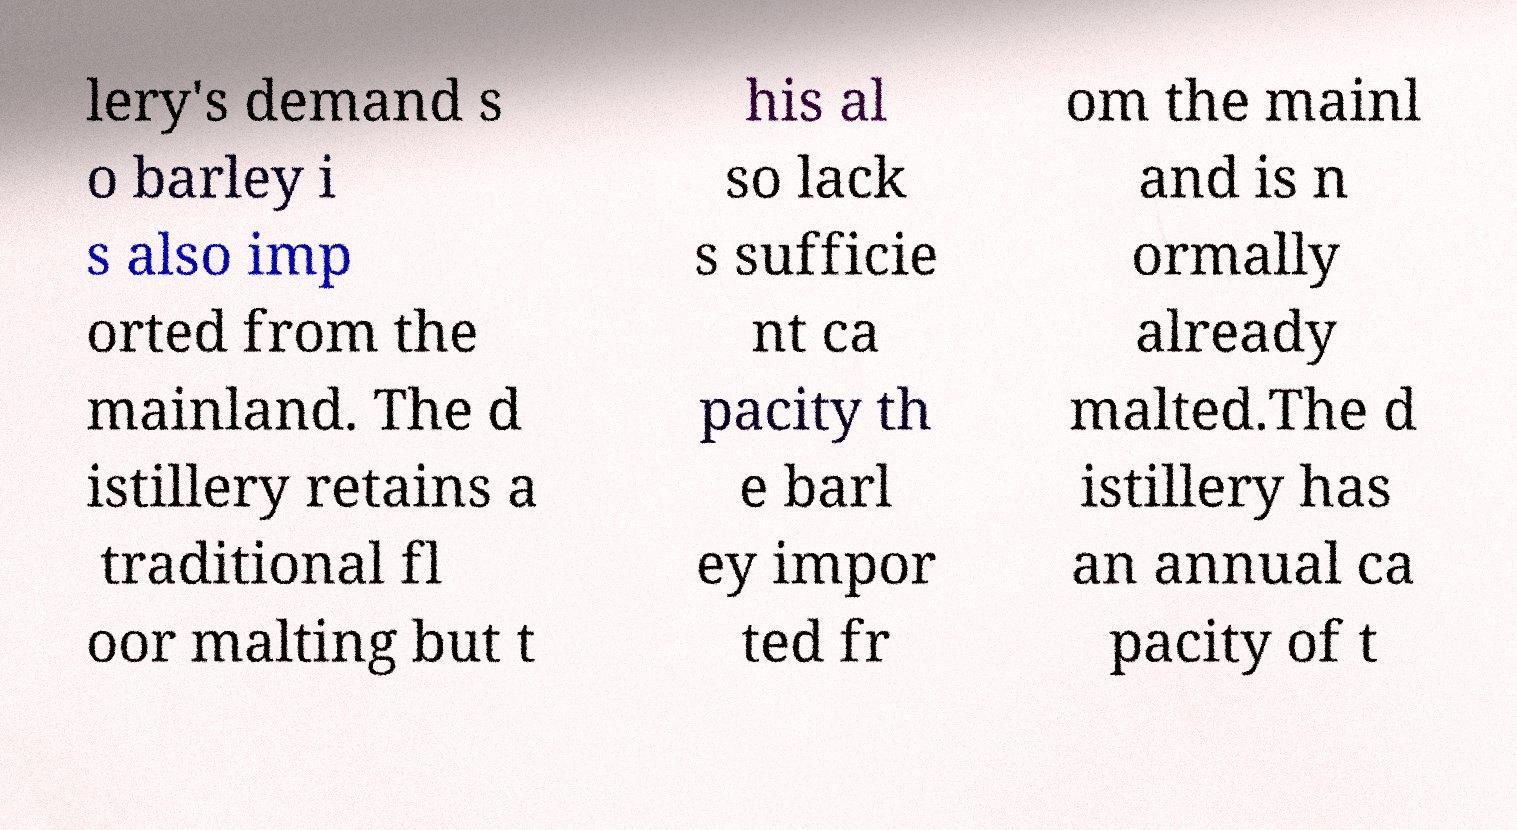Can you read and provide the text displayed in the image?This photo seems to have some interesting text. Can you extract and type it out for me? lery's demand s o barley i s also imp orted from the mainland. The d istillery retains a traditional fl oor malting but t his al so lack s sufficie nt ca pacity th e barl ey impor ted fr om the mainl and is n ormally already malted.The d istillery has an annual ca pacity of t 